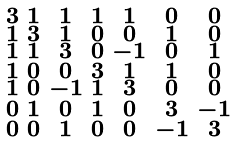<formula> <loc_0><loc_0><loc_500><loc_500>\begin{smallmatrix} 3 & 1 & 1 & 1 & 1 & 0 & 0 \\ 1 & 3 & 1 & 0 & 0 & 1 & 0 \\ 1 & 1 & 3 & 0 & - 1 & 0 & 1 \\ 1 & 0 & 0 & 3 & 1 & 1 & 0 \\ 1 & 0 & - 1 & 1 & 3 & 0 & 0 \\ 0 & 1 & 0 & 1 & 0 & 3 & - 1 \\ 0 & 0 & 1 & 0 & 0 & - 1 & 3 \end{smallmatrix}</formula> 